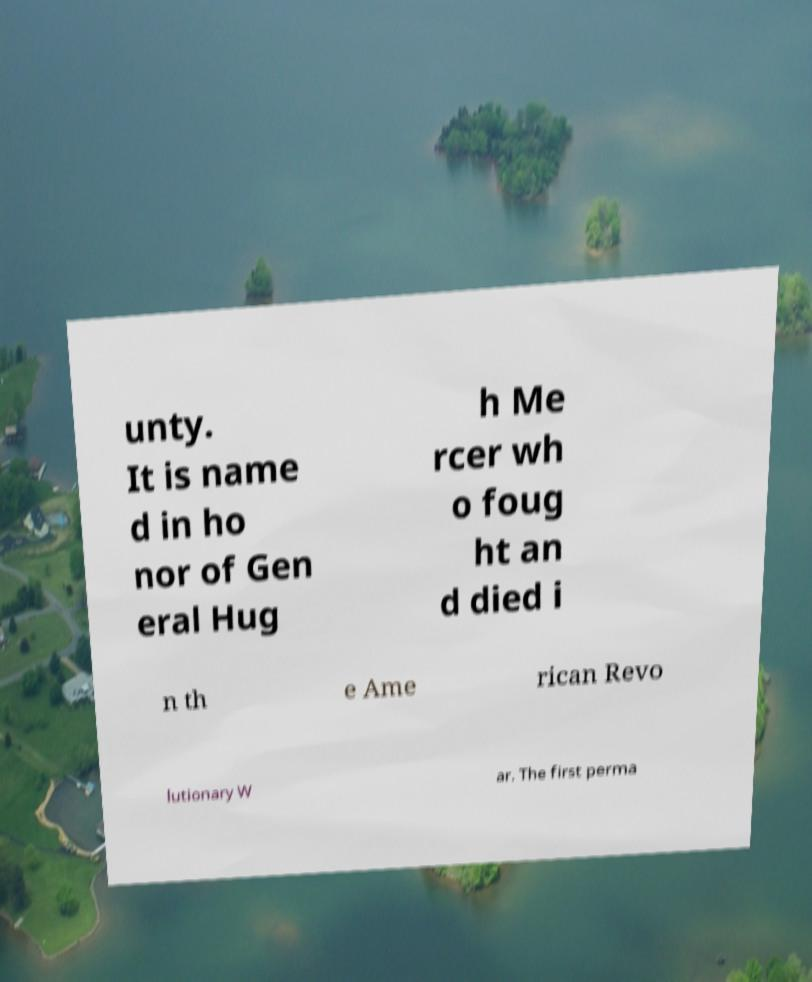Please identify and transcribe the text found in this image. unty. It is name d in ho nor of Gen eral Hug h Me rcer wh o foug ht an d died i n th e Ame rican Revo lutionary W ar. The first perma 